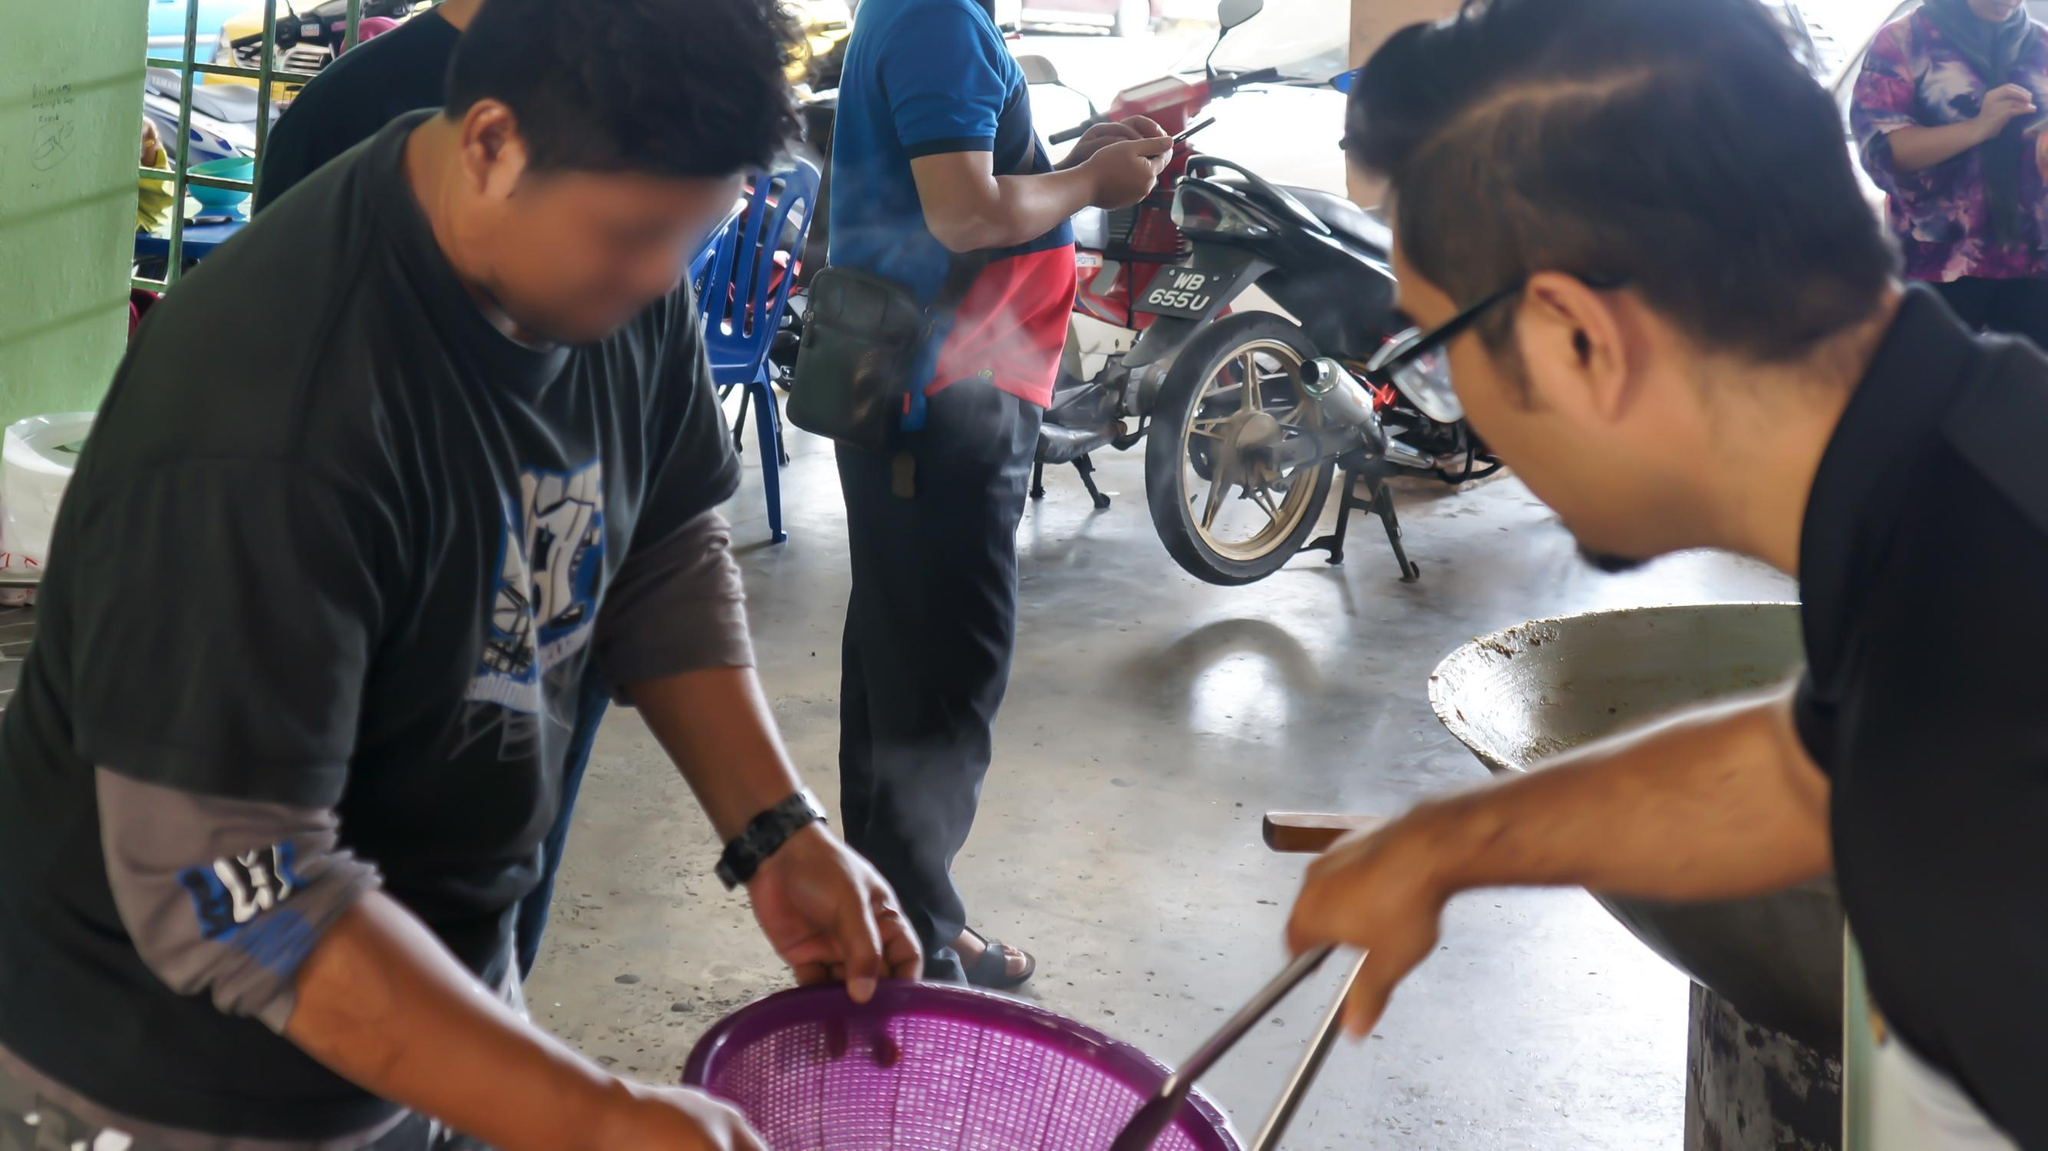What do you think is going on in this snapshot?
 The image captures a bustling scene in a market, where two men are the main focus. One of them is holding a purple basket, while the other is pointing towards it, perhaps discussing the contents or price. They are surrounded by a crowd of people, adding to the lively atmosphere of the market. Motorbikes can be seen in the background, hinting at the mode of transportation preferred in this area.

The image is taken from a low angle, which makes the two men appear larger and more prominent. This perspective also gives us a glimpse of the sky above, contrasting with the crowded market below. The colors in the image are predominantly blue and purple, with splashes of red and green adding vibrancy to the scene.

The image has a slight blur to it, suggesting movement and the dynamic nature of the market. This could be due to the bustling activity in the market or the photographer's intention to convey motion.

As for the landmark, the code "sa_14227" seems to be related to Landmark Global, a shipping service located at 1 Scrivner Dr #5 in Cheektowaga, New York 14227[^2^]. However, without more specific information or context, it's challenging to confidently identify the exact landmark depicted in the image. 